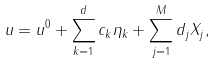<formula> <loc_0><loc_0><loc_500><loc_500>u = u ^ { 0 } + \sum _ { k = 1 } ^ { d } c _ { k } \eta _ { k } + \sum _ { j = 1 } ^ { M } d _ { j } X _ { j } ,</formula> 